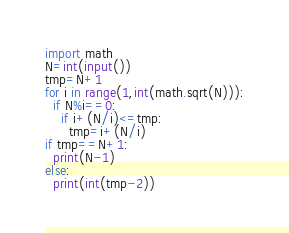Convert code to text. <code><loc_0><loc_0><loc_500><loc_500><_Python_>import math
N=int(input())
tmp=N+1
for i in range(1,int(math.sqrt(N))):
  if N%i==0:
    if i+(N/i)<=tmp:
      tmp=i+(N/i)
if tmp==N+1:
  print(N-1)
else:
  print(int(tmp-2))</code> 